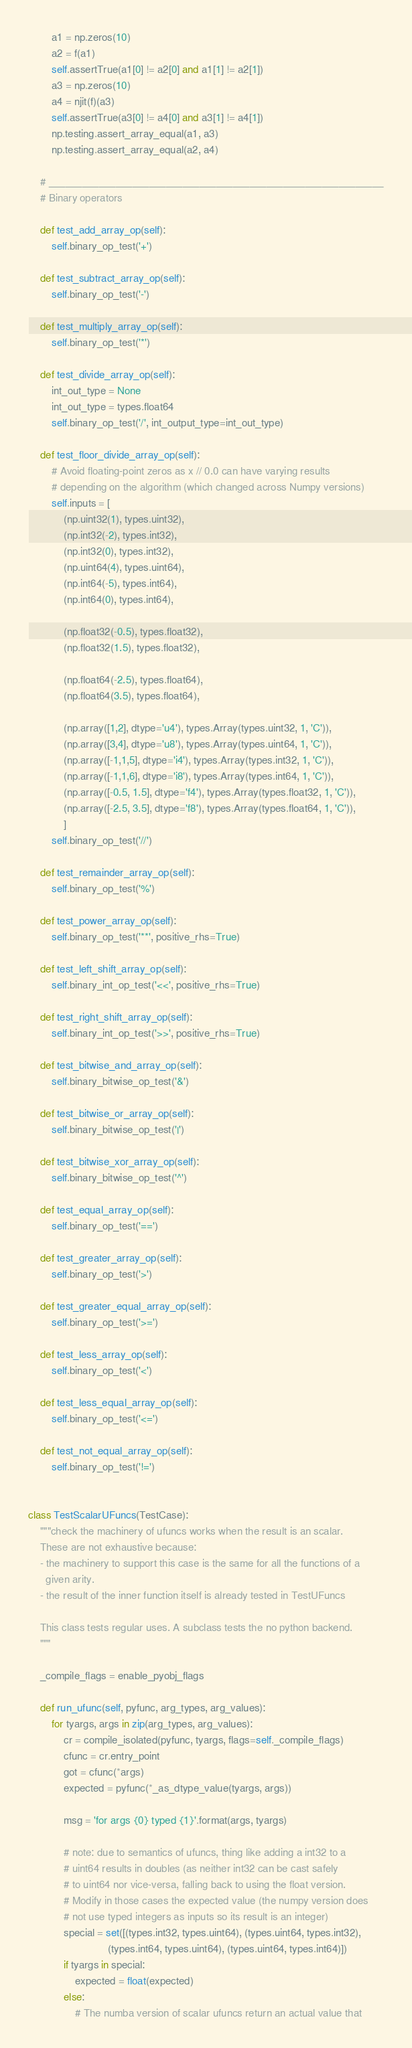<code> <loc_0><loc_0><loc_500><loc_500><_Python_>        a1 = np.zeros(10)
        a2 = f(a1)
        self.assertTrue(a1[0] != a2[0] and a1[1] != a2[1])
        a3 = np.zeros(10)
        a4 = njit(f)(a3)
        self.assertTrue(a3[0] != a4[0] and a3[1] != a4[1])
        np.testing.assert_array_equal(a1, a3)
        np.testing.assert_array_equal(a2, a4)

    # ____________________________________________________________
    # Binary operators

    def test_add_array_op(self):
        self.binary_op_test('+')

    def test_subtract_array_op(self):
        self.binary_op_test('-')

    def test_multiply_array_op(self):
        self.binary_op_test('*')

    def test_divide_array_op(self):
        int_out_type = None
        int_out_type = types.float64
        self.binary_op_test('/', int_output_type=int_out_type)

    def test_floor_divide_array_op(self):
        # Avoid floating-point zeros as x // 0.0 can have varying results
        # depending on the algorithm (which changed across Numpy versions)
        self.inputs = [
            (np.uint32(1), types.uint32),
            (np.int32(-2), types.int32),
            (np.int32(0), types.int32),
            (np.uint64(4), types.uint64),
            (np.int64(-5), types.int64),
            (np.int64(0), types.int64),

            (np.float32(-0.5), types.float32),
            (np.float32(1.5), types.float32),

            (np.float64(-2.5), types.float64),
            (np.float64(3.5), types.float64),

            (np.array([1,2], dtype='u4'), types.Array(types.uint32, 1, 'C')),
            (np.array([3,4], dtype='u8'), types.Array(types.uint64, 1, 'C')),
            (np.array([-1,1,5], dtype='i4'), types.Array(types.int32, 1, 'C')),
            (np.array([-1,1,6], dtype='i8'), types.Array(types.int64, 1, 'C')),
            (np.array([-0.5, 1.5], dtype='f4'), types.Array(types.float32, 1, 'C')),
            (np.array([-2.5, 3.5], dtype='f8'), types.Array(types.float64, 1, 'C')),
            ]
        self.binary_op_test('//')

    def test_remainder_array_op(self):
        self.binary_op_test('%')

    def test_power_array_op(self):
        self.binary_op_test('**', positive_rhs=True)

    def test_left_shift_array_op(self):
        self.binary_int_op_test('<<', positive_rhs=True)

    def test_right_shift_array_op(self):
        self.binary_int_op_test('>>', positive_rhs=True)

    def test_bitwise_and_array_op(self):
        self.binary_bitwise_op_test('&')

    def test_bitwise_or_array_op(self):
        self.binary_bitwise_op_test('|')

    def test_bitwise_xor_array_op(self):
        self.binary_bitwise_op_test('^')

    def test_equal_array_op(self):
        self.binary_op_test('==')

    def test_greater_array_op(self):
        self.binary_op_test('>')

    def test_greater_equal_array_op(self):
        self.binary_op_test('>=')

    def test_less_array_op(self):
        self.binary_op_test('<')

    def test_less_equal_array_op(self):
        self.binary_op_test('<=')

    def test_not_equal_array_op(self):
        self.binary_op_test('!=')


class TestScalarUFuncs(TestCase):
    """check the machinery of ufuncs works when the result is an scalar.
    These are not exhaustive because:
    - the machinery to support this case is the same for all the functions of a
      given arity.
    - the result of the inner function itself is already tested in TestUFuncs

    This class tests regular uses. A subclass tests the no python backend.
    """

    _compile_flags = enable_pyobj_flags

    def run_ufunc(self, pyfunc, arg_types, arg_values):
        for tyargs, args in zip(arg_types, arg_values):
            cr = compile_isolated(pyfunc, tyargs, flags=self._compile_flags)
            cfunc = cr.entry_point
            got = cfunc(*args)
            expected = pyfunc(*_as_dtype_value(tyargs, args))

            msg = 'for args {0} typed {1}'.format(args, tyargs)

            # note: due to semantics of ufuncs, thing like adding a int32 to a
            # uint64 results in doubles (as neither int32 can be cast safely
            # to uint64 nor vice-versa, falling back to using the float version.
            # Modify in those cases the expected value (the numpy version does
            # not use typed integers as inputs so its result is an integer)
            special = set([(types.int32, types.uint64), (types.uint64, types.int32),
                           (types.int64, types.uint64), (types.uint64, types.int64)])
            if tyargs in special:
                expected = float(expected)
            else:
                # The numba version of scalar ufuncs return an actual value that</code> 